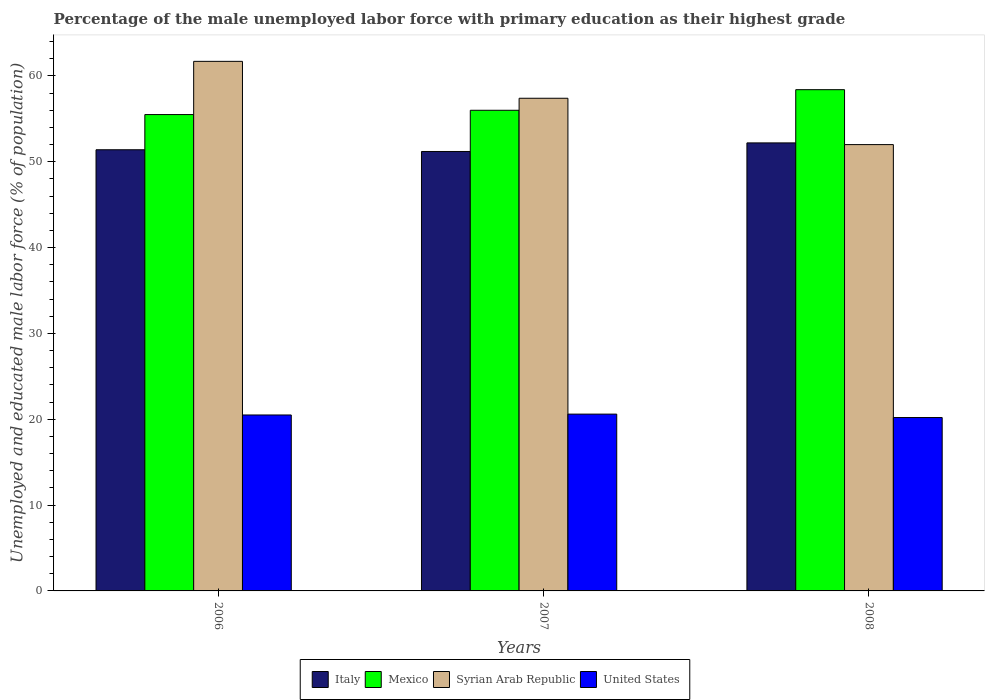How many different coloured bars are there?
Your response must be concise. 4. Are the number of bars on each tick of the X-axis equal?
Keep it short and to the point. Yes. How many bars are there on the 3rd tick from the left?
Your answer should be compact. 4. What is the label of the 2nd group of bars from the left?
Your answer should be very brief. 2007. What is the percentage of the unemployed male labor force with primary education in Syrian Arab Republic in 2007?
Offer a terse response. 57.4. Across all years, what is the maximum percentage of the unemployed male labor force with primary education in Mexico?
Ensure brevity in your answer.  58.4. Across all years, what is the minimum percentage of the unemployed male labor force with primary education in United States?
Ensure brevity in your answer.  20.2. What is the total percentage of the unemployed male labor force with primary education in United States in the graph?
Your response must be concise. 61.3. What is the difference between the percentage of the unemployed male labor force with primary education in United States in 2007 and that in 2008?
Provide a succinct answer. 0.4. What is the difference between the percentage of the unemployed male labor force with primary education in Syrian Arab Republic in 2008 and the percentage of the unemployed male labor force with primary education in Italy in 2007?
Your answer should be compact. 0.8. What is the average percentage of the unemployed male labor force with primary education in Italy per year?
Give a very brief answer. 51.6. In the year 2006, what is the difference between the percentage of the unemployed male labor force with primary education in Italy and percentage of the unemployed male labor force with primary education in Mexico?
Offer a terse response. -4.1. In how many years, is the percentage of the unemployed male labor force with primary education in Italy greater than 10 %?
Your answer should be very brief. 3. What is the ratio of the percentage of the unemployed male labor force with primary education in Syrian Arab Republic in 2006 to that in 2008?
Make the answer very short. 1.19. Is the difference between the percentage of the unemployed male labor force with primary education in Italy in 2007 and 2008 greater than the difference between the percentage of the unemployed male labor force with primary education in Mexico in 2007 and 2008?
Provide a succinct answer. Yes. What is the difference between the highest and the second highest percentage of the unemployed male labor force with primary education in Syrian Arab Republic?
Offer a terse response. 4.3. What is the difference between the highest and the lowest percentage of the unemployed male labor force with primary education in Mexico?
Your response must be concise. 2.9. Is the sum of the percentage of the unemployed male labor force with primary education in Mexico in 2007 and 2008 greater than the maximum percentage of the unemployed male labor force with primary education in Italy across all years?
Keep it short and to the point. Yes. What does the 1st bar from the left in 2007 represents?
Offer a terse response. Italy. What does the 2nd bar from the right in 2006 represents?
Give a very brief answer. Syrian Arab Republic. Is it the case that in every year, the sum of the percentage of the unemployed male labor force with primary education in United States and percentage of the unemployed male labor force with primary education in Italy is greater than the percentage of the unemployed male labor force with primary education in Syrian Arab Republic?
Offer a very short reply. Yes. How many bars are there?
Give a very brief answer. 12. How many years are there in the graph?
Your response must be concise. 3. What is the difference between two consecutive major ticks on the Y-axis?
Give a very brief answer. 10. Does the graph contain grids?
Offer a terse response. No. Where does the legend appear in the graph?
Offer a terse response. Bottom center. How many legend labels are there?
Keep it short and to the point. 4. What is the title of the graph?
Your answer should be compact. Percentage of the male unemployed labor force with primary education as their highest grade. What is the label or title of the X-axis?
Keep it short and to the point. Years. What is the label or title of the Y-axis?
Provide a succinct answer. Unemployed and educated male labor force (% of population). What is the Unemployed and educated male labor force (% of population) in Italy in 2006?
Provide a short and direct response. 51.4. What is the Unemployed and educated male labor force (% of population) in Mexico in 2006?
Ensure brevity in your answer.  55.5. What is the Unemployed and educated male labor force (% of population) of Syrian Arab Republic in 2006?
Ensure brevity in your answer.  61.7. What is the Unemployed and educated male labor force (% of population) in United States in 2006?
Keep it short and to the point. 20.5. What is the Unemployed and educated male labor force (% of population) of Italy in 2007?
Provide a short and direct response. 51.2. What is the Unemployed and educated male labor force (% of population) of Syrian Arab Republic in 2007?
Your answer should be compact. 57.4. What is the Unemployed and educated male labor force (% of population) of United States in 2007?
Ensure brevity in your answer.  20.6. What is the Unemployed and educated male labor force (% of population) of Italy in 2008?
Offer a terse response. 52.2. What is the Unemployed and educated male labor force (% of population) in Mexico in 2008?
Offer a terse response. 58.4. What is the Unemployed and educated male labor force (% of population) of United States in 2008?
Provide a succinct answer. 20.2. Across all years, what is the maximum Unemployed and educated male labor force (% of population) of Italy?
Offer a very short reply. 52.2. Across all years, what is the maximum Unemployed and educated male labor force (% of population) in Mexico?
Your answer should be compact. 58.4. Across all years, what is the maximum Unemployed and educated male labor force (% of population) of Syrian Arab Republic?
Provide a short and direct response. 61.7. Across all years, what is the maximum Unemployed and educated male labor force (% of population) of United States?
Provide a succinct answer. 20.6. Across all years, what is the minimum Unemployed and educated male labor force (% of population) in Italy?
Provide a short and direct response. 51.2. Across all years, what is the minimum Unemployed and educated male labor force (% of population) of Mexico?
Offer a terse response. 55.5. Across all years, what is the minimum Unemployed and educated male labor force (% of population) of Syrian Arab Republic?
Offer a terse response. 52. Across all years, what is the minimum Unemployed and educated male labor force (% of population) of United States?
Ensure brevity in your answer.  20.2. What is the total Unemployed and educated male labor force (% of population) of Italy in the graph?
Your answer should be compact. 154.8. What is the total Unemployed and educated male labor force (% of population) in Mexico in the graph?
Ensure brevity in your answer.  169.9. What is the total Unemployed and educated male labor force (% of population) in Syrian Arab Republic in the graph?
Your answer should be very brief. 171.1. What is the total Unemployed and educated male labor force (% of population) in United States in the graph?
Keep it short and to the point. 61.3. What is the difference between the Unemployed and educated male labor force (% of population) in Italy in 2006 and that in 2007?
Provide a short and direct response. 0.2. What is the difference between the Unemployed and educated male labor force (% of population) in Mexico in 2006 and that in 2007?
Keep it short and to the point. -0.5. What is the difference between the Unemployed and educated male labor force (% of population) of United States in 2006 and that in 2007?
Your answer should be compact. -0.1. What is the difference between the Unemployed and educated male labor force (% of population) of Mexico in 2006 and that in 2008?
Provide a succinct answer. -2.9. What is the difference between the Unemployed and educated male labor force (% of population) of United States in 2006 and that in 2008?
Your response must be concise. 0.3. What is the difference between the Unemployed and educated male labor force (% of population) of Italy in 2007 and that in 2008?
Provide a short and direct response. -1. What is the difference between the Unemployed and educated male labor force (% of population) in Mexico in 2007 and that in 2008?
Your response must be concise. -2.4. What is the difference between the Unemployed and educated male labor force (% of population) in Italy in 2006 and the Unemployed and educated male labor force (% of population) in United States in 2007?
Offer a terse response. 30.8. What is the difference between the Unemployed and educated male labor force (% of population) in Mexico in 2006 and the Unemployed and educated male labor force (% of population) in Syrian Arab Republic in 2007?
Make the answer very short. -1.9. What is the difference between the Unemployed and educated male labor force (% of population) in Mexico in 2006 and the Unemployed and educated male labor force (% of population) in United States in 2007?
Your response must be concise. 34.9. What is the difference between the Unemployed and educated male labor force (% of population) in Syrian Arab Republic in 2006 and the Unemployed and educated male labor force (% of population) in United States in 2007?
Offer a very short reply. 41.1. What is the difference between the Unemployed and educated male labor force (% of population) of Italy in 2006 and the Unemployed and educated male labor force (% of population) of Syrian Arab Republic in 2008?
Provide a short and direct response. -0.6. What is the difference between the Unemployed and educated male labor force (% of population) of Italy in 2006 and the Unemployed and educated male labor force (% of population) of United States in 2008?
Offer a very short reply. 31.2. What is the difference between the Unemployed and educated male labor force (% of population) in Mexico in 2006 and the Unemployed and educated male labor force (% of population) in Syrian Arab Republic in 2008?
Provide a succinct answer. 3.5. What is the difference between the Unemployed and educated male labor force (% of population) in Mexico in 2006 and the Unemployed and educated male labor force (% of population) in United States in 2008?
Your answer should be compact. 35.3. What is the difference between the Unemployed and educated male labor force (% of population) of Syrian Arab Republic in 2006 and the Unemployed and educated male labor force (% of population) of United States in 2008?
Keep it short and to the point. 41.5. What is the difference between the Unemployed and educated male labor force (% of population) of Italy in 2007 and the Unemployed and educated male labor force (% of population) of Mexico in 2008?
Your response must be concise. -7.2. What is the difference between the Unemployed and educated male labor force (% of population) of Mexico in 2007 and the Unemployed and educated male labor force (% of population) of Syrian Arab Republic in 2008?
Provide a succinct answer. 4. What is the difference between the Unemployed and educated male labor force (% of population) of Mexico in 2007 and the Unemployed and educated male labor force (% of population) of United States in 2008?
Offer a terse response. 35.8. What is the difference between the Unemployed and educated male labor force (% of population) of Syrian Arab Republic in 2007 and the Unemployed and educated male labor force (% of population) of United States in 2008?
Ensure brevity in your answer.  37.2. What is the average Unemployed and educated male labor force (% of population) in Italy per year?
Give a very brief answer. 51.6. What is the average Unemployed and educated male labor force (% of population) of Mexico per year?
Make the answer very short. 56.63. What is the average Unemployed and educated male labor force (% of population) of Syrian Arab Republic per year?
Provide a short and direct response. 57.03. What is the average Unemployed and educated male labor force (% of population) of United States per year?
Your answer should be compact. 20.43. In the year 2006, what is the difference between the Unemployed and educated male labor force (% of population) in Italy and Unemployed and educated male labor force (% of population) in Mexico?
Offer a terse response. -4.1. In the year 2006, what is the difference between the Unemployed and educated male labor force (% of population) of Italy and Unemployed and educated male labor force (% of population) of United States?
Provide a succinct answer. 30.9. In the year 2006, what is the difference between the Unemployed and educated male labor force (% of population) in Mexico and Unemployed and educated male labor force (% of population) in United States?
Give a very brief answer. 35. In the year 2006, what is the difference between the Unemployed and educated male labor force (% of population) in Syrian Arab Republic and Unemployed and educated male labor force (% of population) in United States?
Keep it short and to the point. 41.2. In the year 2007, what is the difference between the Unemployed and educated male labor force (% of population) of Italy and Unemployed and educated male labor force (% of population) of United States?
Offer a very short reply. 30.6. In the year 2007, what is the difference between the Unemployed and educated male labor force (% of population) in Mexico and Unemployed and educated male labor force (% of population) in United States?
Provide a succinct answer. 35.4. In the year 2007, what is the difference between the Unemployed and educated male labor force (% of population) in Syrian Arab Republic and Unemployed and educated male labor force (% of population) in United States?
Make the answer very short. 36.8. In the year 2008, what is the difference between the Unemployed and educated male labor force (% of population) of Italy and Unemployed and educated male labor force (% of population) of Mexico?
Your answer should be very brief. -6.2. In the year 2008, what is the difference between the Unemployed and educated male labor force (% of population) in Italy and Unemployed and educated male labor force (% of population) in Syrian Arab Republic?
Keep it short and to the point. 0.2. In the year 2008, what is the difference between the Unemployed and educated male labor force (% of population) in Italy and Unemployed and educated male labor force (% of population) in United States?
Provide a succinct answer. 32. In the year 2008, what is the difference between the Unemployed and educated male labor force (% of population) in Mexico and Unemployed and educated male labor force (% of population) in Syrian Arab Republic?
Offer a terse response. 6.4. In the year 2008, what is the difference between the Unemployed and educated male labor force (% of population) in Mexico and Unemployed and educated male labor force (% of population) in United States?
Your answer should be compact. 38.2. In the year 2008, what is the difference between the Unemployed and educated male labor force (% of population) in Syrian Arab Republic and Unemployed and educated male labor force (% of population) in United States?
Your response must be concise. 31.8. What is the ratio of the Unemployed and educated male labor force (% of population) of Italy in 2006 to that in 2007?
Your answer should be very brief. 1. What is the ratio of the Unemployed and educated male labor force (% of population) in Mexico in 2006 to that in 2007?
Your answer should be compact. 0.99. What is the ratio of the Unemployed and educated male labor force (% of population) in Syrian Arab Republic in 2006 to that in 2007?
Your answer should be very brief. 1.07. What is the ratio of the Unemployed and educated male labor force (% of population) of United States in 2006 to that in 2007?
Provide a succinct answer. 1. What is the ratio of the Unemployed and educated male labor force (% of population) of Italy in 2006 to that in 2008?
Ensure brevity in your answer.  0.98. What is the ratio of the Unemployed and educated male labor force (% of population) of Mexico in 2006 to that in 2008?
Offer a very short reply. 0.95. What is the ratio of the Unemployed and educated male labor force (% of population) in Syrian Arab Republic in 2006 to that in 2008?
Your answer should be very brief. 1.19. What is the ratio of the Unemployed and educated male labor force (% of population) of United States in 2006 to that in 2008?
Give a very brief answer. 1.01. What is the ratio of the Unemployed and educated male labor force (% of population) of Italy in 2007 to that in 2008?
Make the answer very short. 0.98. What is the ratio of the Unemployed and educated male labor force (% of population) in Mexico in 2007 to that in 2008?
Offer a terse response. 0.96. What is the ratio of the Unemployed and educated male labor force (% of population) in Syrian Arab Republic in 2007 to that in 2008?
Make the answer very short. 1.1. What is the ratio of the Unemployed and educated male labor force (% of population) of United States in 2007 to that in 2008?
Your response must be concise. 1.02. What is the difference between the highest and the second highest Unemployed and educated male labor force (% of population) in Mexico?
Offer a very short reply. 2.4. What is the difference between the highest and the second highest Unemployed and educated male labor force (% of population) of United States?
Offer a very short reply. 0.1. What is the difference between the highest and the lowest Unemployed and educated male labor force (% of population) in Italy?
Your answer should be very brief. 1. 